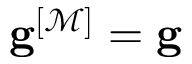<formula> <loc_0><loc_0><loc_500><loc_500>g ^ { [ \mathcal { M } ] } = g</formula> 